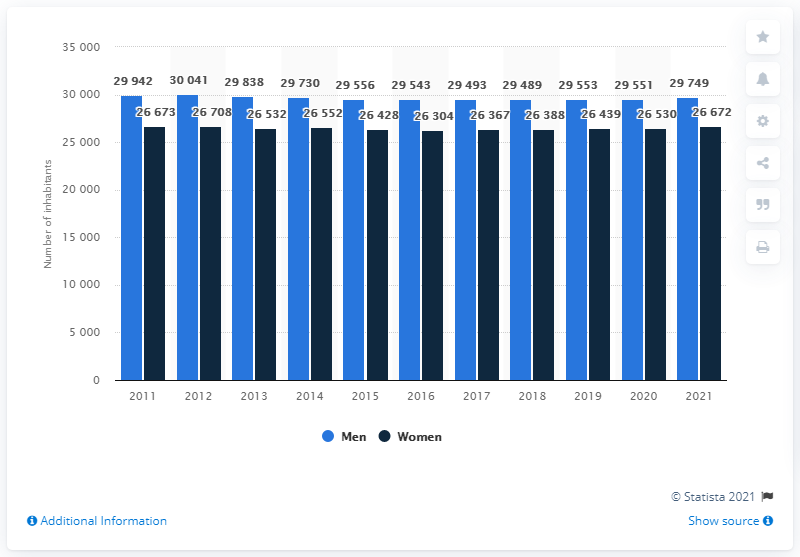Outline some significant characteristics in this image. As of 2021, it is estimated that there are 29,749 males living in Greenland. 